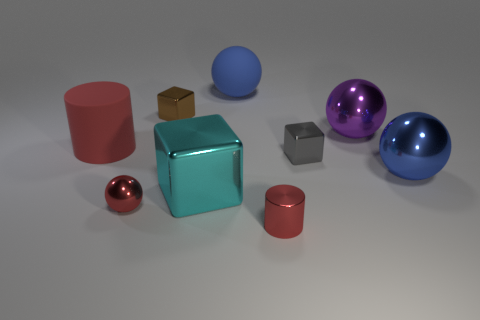Can you describe the colors of the objects and how they might affect the image's overall aesthetic? Certainly, the image features objects in bold primary and secondary colors such as red, blue, and teal, as well as subtler shades like gray and brown. These colors are balanced in a way that creates a harmonious visual experience. The brighter colored objects stand out and draw attention, while the neutral gray objects provide a calm background. This combination results in a visually appealing and dynamic composition. 